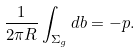Convert formula to latex. <formula><loc_0><loc_0><loc_500><loc_500>\frac { 1 } { 2 \pi R } \int _ { \Sigma _ { g } } d b = - p .</formula> 